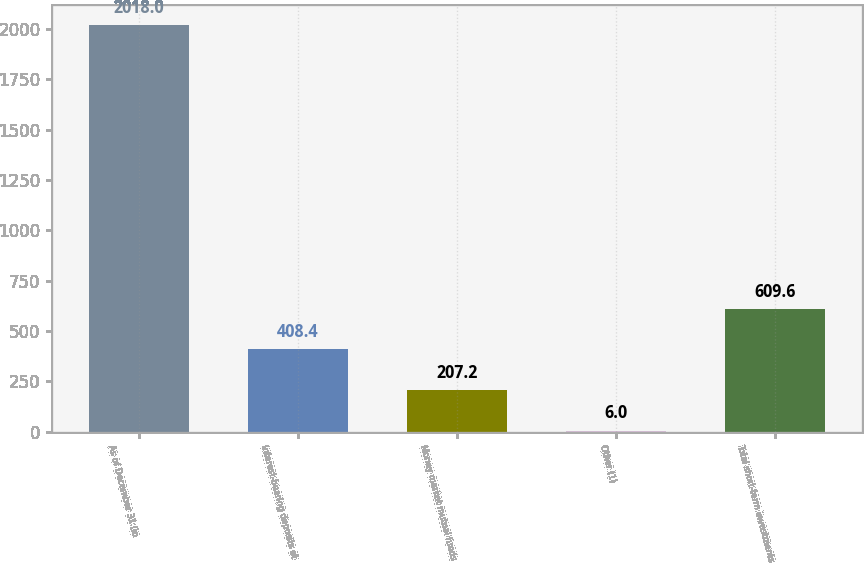<chart> <loc_0><loc_0><loc_500><loc_500><bar_chart><fcel>As of December 31 (in<fcel>Interest-bearing deposits at<fcel>Money market mutual funds<fcel>Other (1)<fcel>Total short-term investments<nl><fcel>2018<fcel>408.4<fcel>207.2<fcel>6<fcel>609.6<nl></chart> 